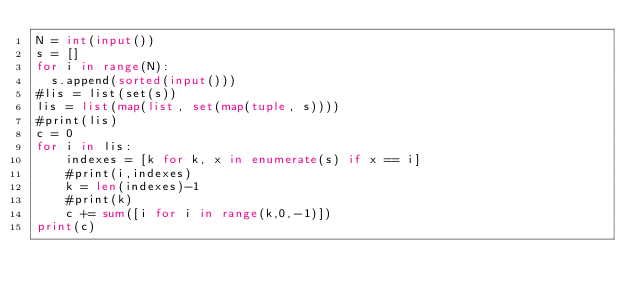Convert code to text. <code><loc_0><loc_0><loc_500><loc_500><_Python_>N = int(input())
s = []
for i in range(N):
  s.append(sorted(input()))
#lis = list(set(s))
lis = list(map(list, set(map(tuple, s))))
#print(lis)
c = 0
for i in lis:
    indexes = [k for k, x in enumerate(s) if x == i]
    #print(i,indexes)
    k = len(indexes)-1
    #print(k)
    c += sum([i for i in range(k,0,-1)])
print(c)</code> 